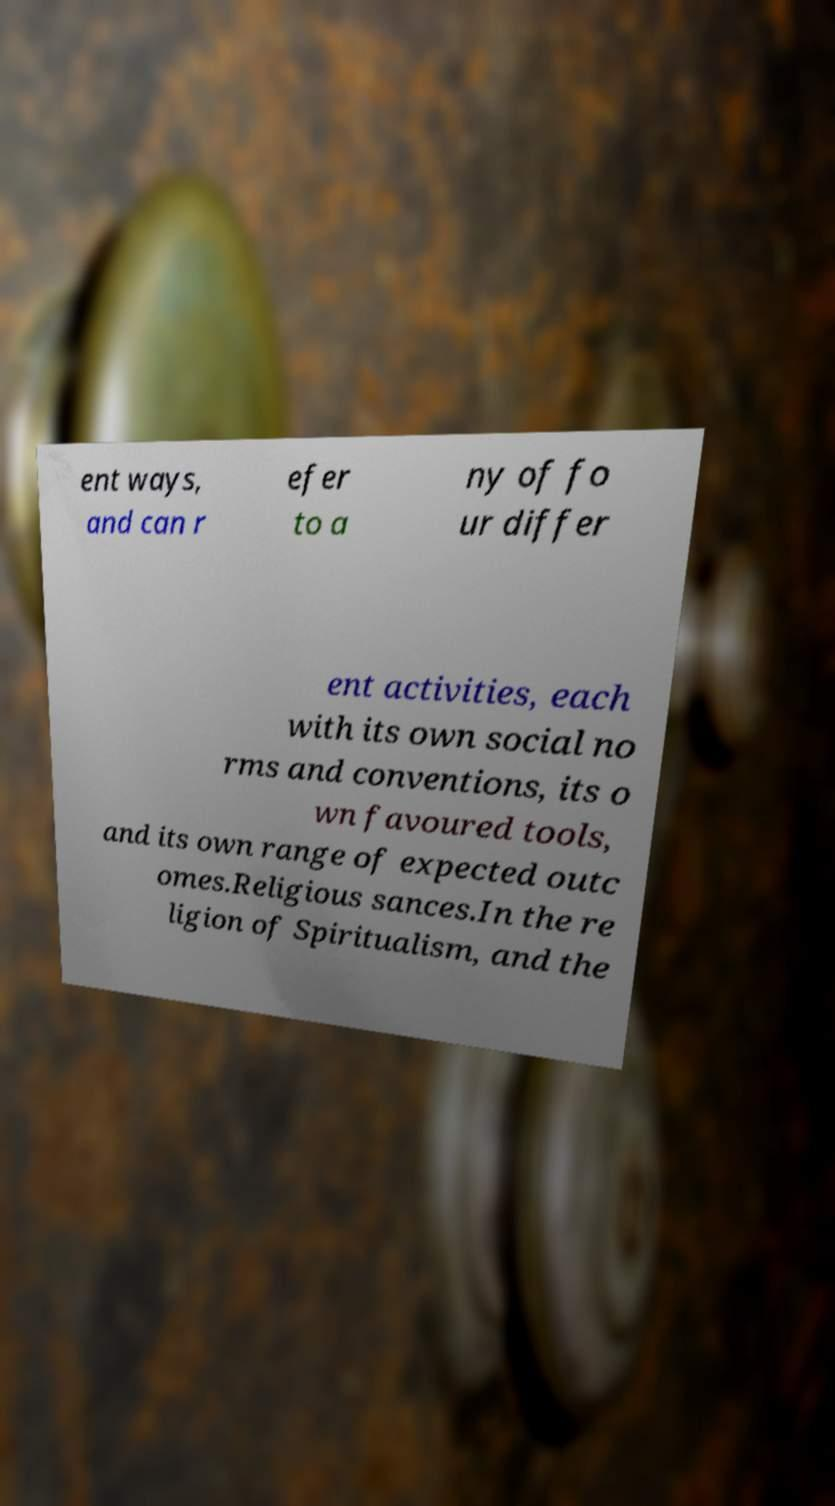Could you extract and type out the text from this image? ent ways, and can r efer to a ny of fo ur differ ent activities, each with its own social no rms and conventions, its o wn favoured tools, and its own range of expected outc omes.Religious sances.In the re ligion of Spiritualism, and the 